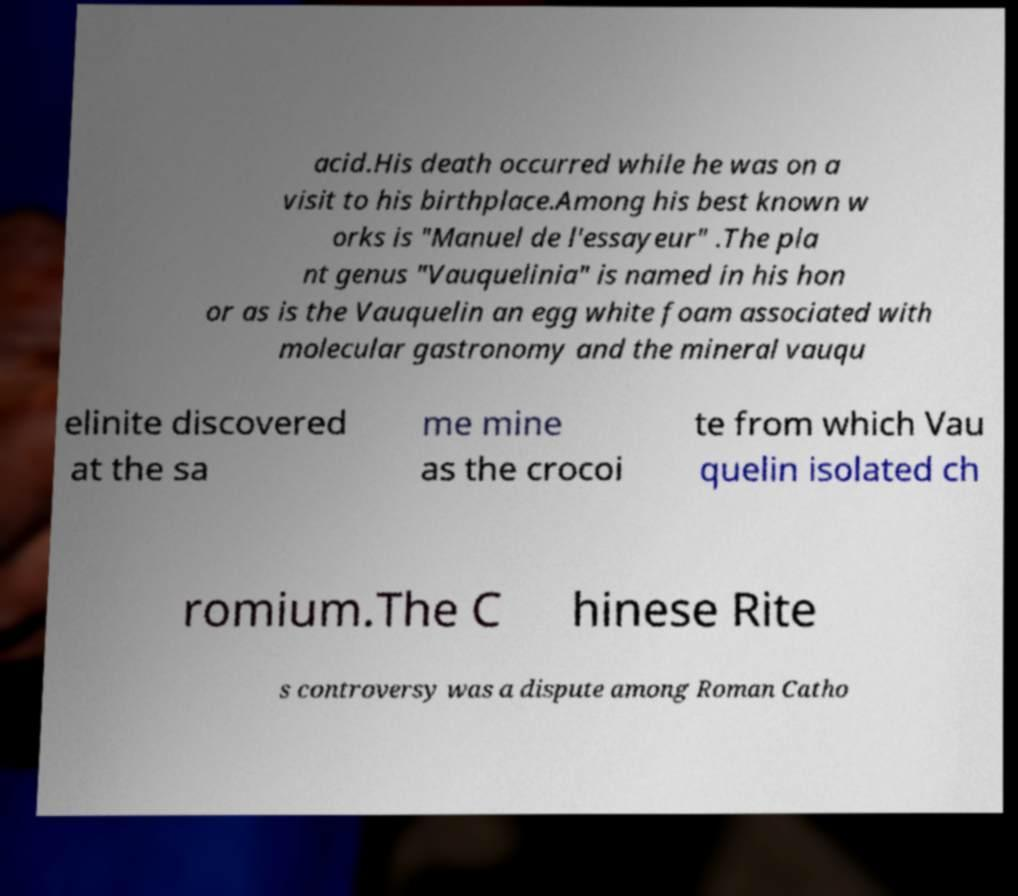I need the written content from this picture converted into text. Can you do that? acid.His death occurred while he was on a visit to his birthplace.Among his best known w orks is "Manuel de l'essayeur" .The pla nt genus "Vauquelinia" is named in his hon or as is the Vauquelin an egg white foam associated with molecular gastronomy and the mineral vauqu elinite discovered at the sa me mine as the crocoi te from which Vau quelin isolated ch romium.The C hinese Rite s controversy was a dispute among Roman Catho 